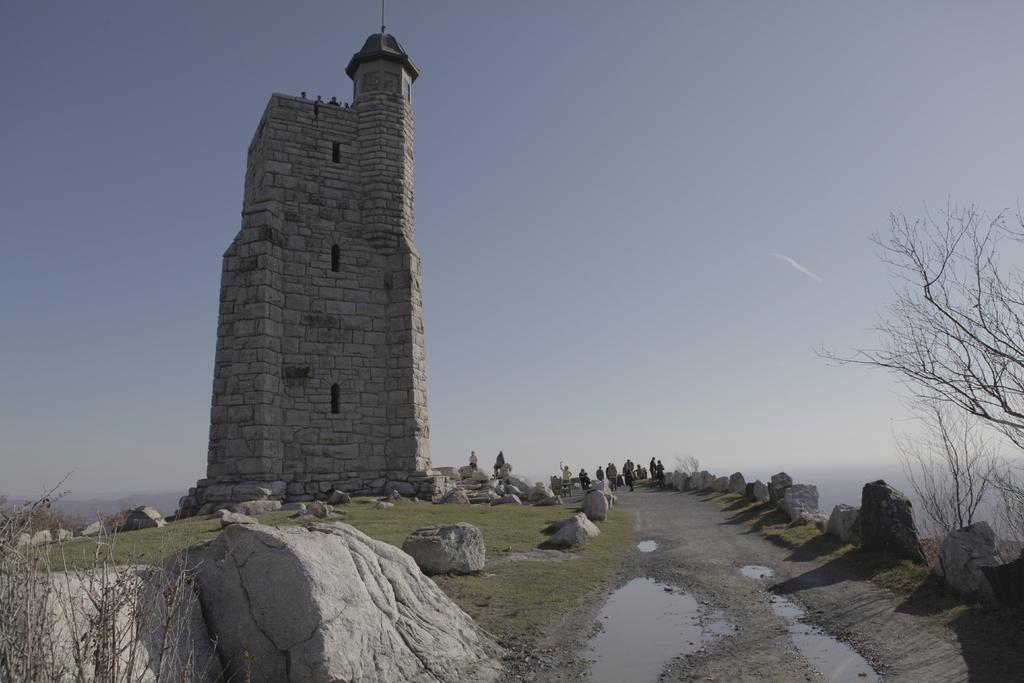What type of structure is present in the image? There is a building in the image. Where are the groups of people located in relation to the building? The groups of people are on the right side of the building. What natural elements can be seen in the image? There are rocks and trees in the image. What is visible behind the building? The sky is visible behind the building. How does the building use its mind to communicate with the trees? Buildings do not have minds, so they cannot communicate with trees. 